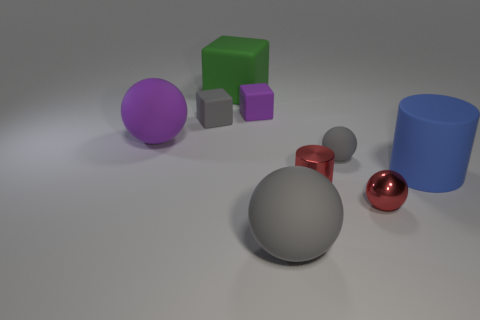Subtract all small gray blocks. How many blocks are left? 2 Subtract all purple blocks. How many blocks are left? 2 Subtract 2 cubes. How many cubes are left? 1 Subtract all spheres. How many objects are left? 5 Add 1 tiny matte things. How many objects exist? 10 Subtract 1 purple cubes. How many objects are left? 8 Subtract all red balls. Subtract all cyan cylinders. How many balls are left? 3 Subtract all purple balls. How many blue cylinders are left? 1 Subtract all cyan metallic objects. Subtract all large green matte blocks. How many objects are left? 8 Add 4 blue objects. How many blue objects are left? 5 